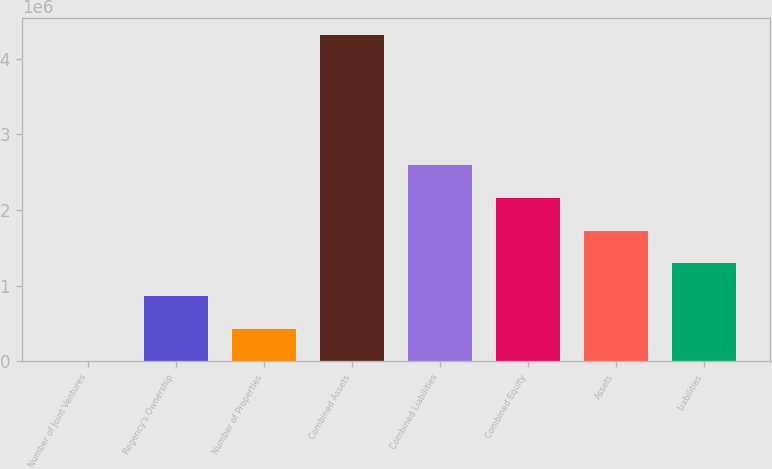Convert chart. <chart><loc_0><loc_0><loc_500><loc_500><bar_chart><fcel>Number of Joint Ventures<fcel>Regency's Ownership<fcel>Number of Properties<fcel>Combined Assets<fcel>Combined Liabilities<fcel>Combined Equity<fcel>Assets<fcel>Liabilities<nl><fcel>15<fcel>863728<fcel>431872<fcel>4.31858e+06<fcel>2.59115e+06<fcel>2.1593e+06<fcel>1.72744e+06<fcel>1.29558e+06<nl></chart> 